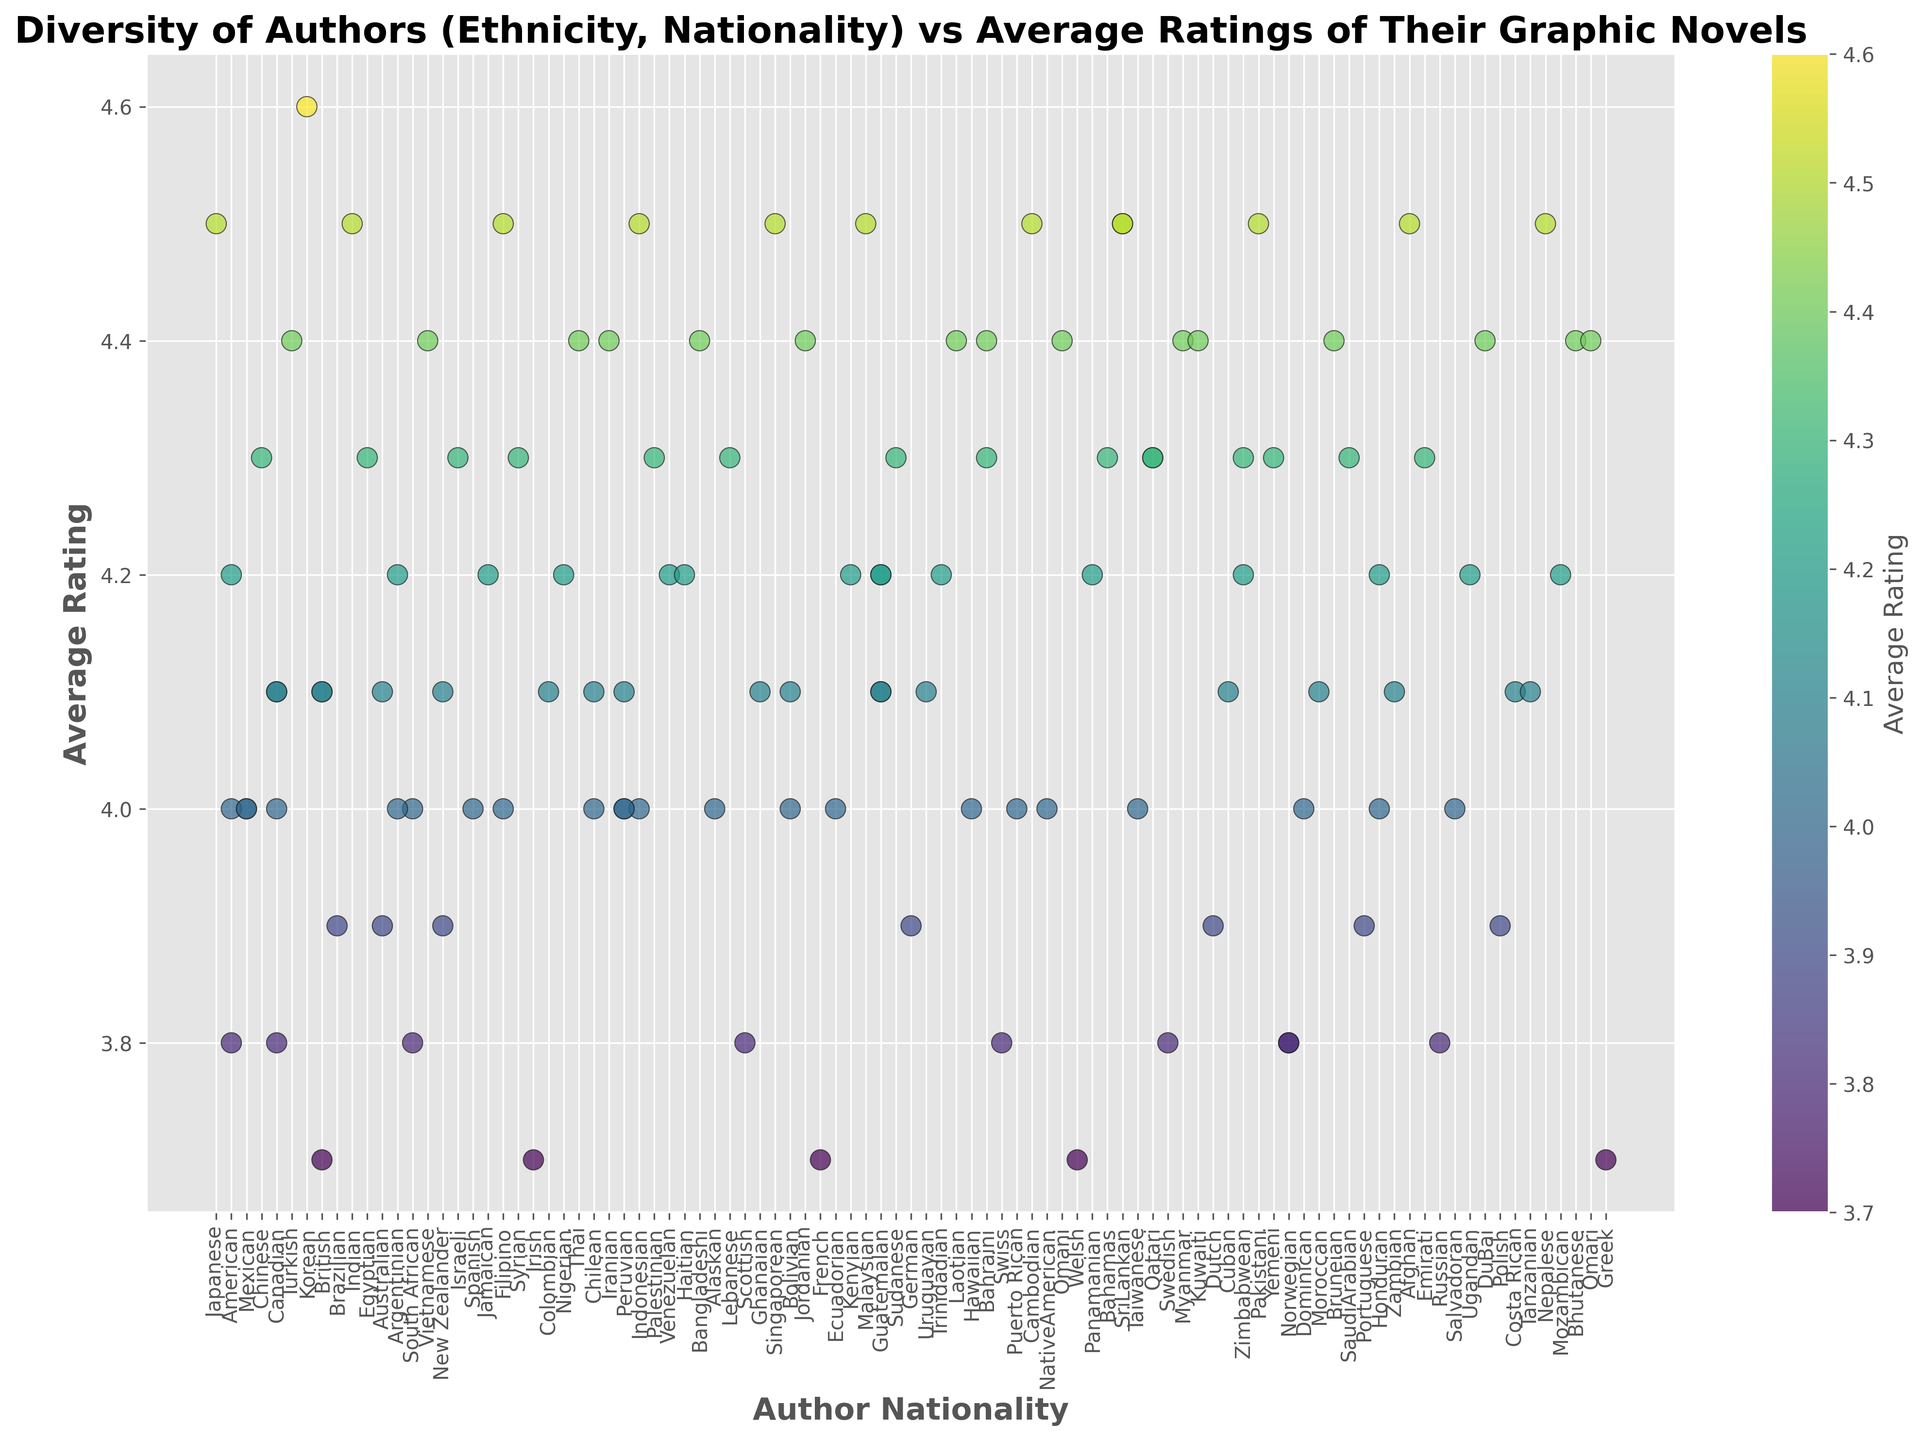What is the nationality of the author with the highest average rating? The figure shows that one author with an Asian ethnicity, from Korea, has the highest average rating of 4.6. To find the nationality corresponding to this rating, I located the point with the highest rating on the y-axis and then checked the x-axis for the nationality.
Answer: Korean How many different author ethnicities have average ratings of 4.5? By looking at the scatter plot, I found multiple points on the figure with an average rating of 4.5 on the y-axis, each having a different nationality. After matching each of these points with their corresponding ethnicities on the x-axis labels, I counted the number of unique ethnicities.
Answer: 7 Which author nationality has the lowest average rating and what is that rating? Looking at the bottom-most points on the y-axis, I noticed multiple points at around the lowest average rating of 3.7. I then checked the corresponding nationalities along the x-axis.
Answer: British, French, Irish, Welsh, Greek What is the average rating difference between authors with Asian and White ethnicities? To find the average rating for each ethnicity, I found and averaged the ratings for all Asian authors and all White authors separately from the scatter plot. I then calculated the difference between these two average ratings.
Answer: 0.7 Are there any Middle Eastern authors with an average rating higher than 4.4? Scanning through the Middle Eastern authors on the scatter plot, I searched for any points with an average rating greater than 4.4. There were no points with ratings higher than 4.4 for Middle Eastern authors.
Answer: No Which nationality among Latino authors has the highest average rating and what is it? Checking through all the Latino authors on the scatter plot, I identified the highest point for this group on the y-axis and noted its rating and corresponding nationality on the x-axis.
Answer: Panamanian, 4.2 